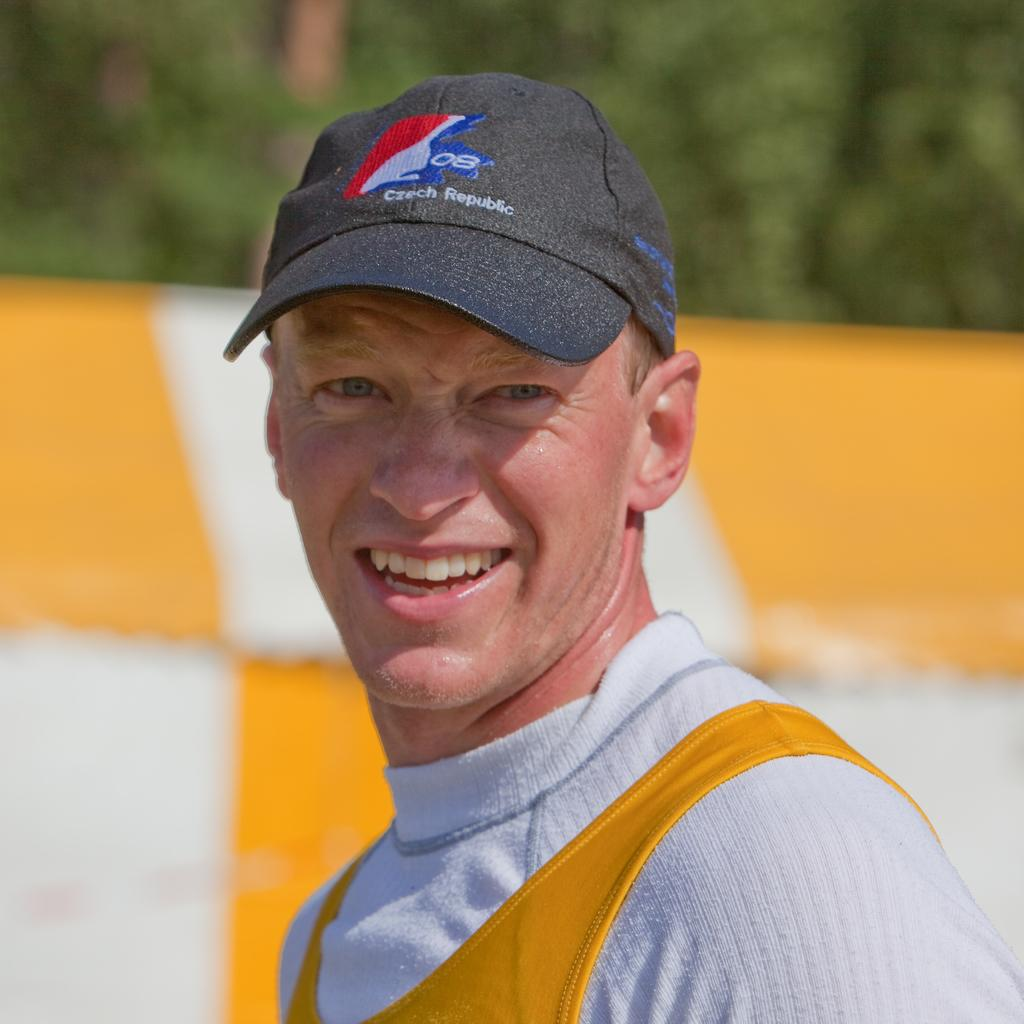<image>
Offer a succinct explanation of the picture presented. Man smiling and wearing a cap that says Czech Republic on it. 